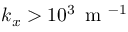Convert formula to latex. <formula><loc_0><loc_0><loc_500><loc_500>k _ { x } > 1 0 ^ { 3 } \, m ^ { - 1 }</formula> 